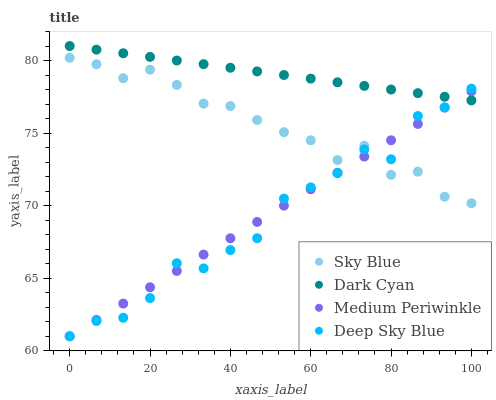Does Deep Sky Blue have the minimum area under the curve?
Answer yes or no. Yes. Does Dark Cyan have the maximum area under the curve?
Answer yes or no. Yes. Does Sky Blue have the minimum area under the curve?
Answer yes or no. No. Does Sky Blue have the maximum area under the curve?
Answer yes or no. No. Is Medium Periwinkle the smoothest?
Answer yes or no. Yes. Is Deep Sky Blue the roughest?
Answer yes or no. Yes. Is Sky Blue the smoothest?
Answer yes or no. No. Is Sky Blue the roughest?
Answer yes or no. No. Does Medium Periwinkle have the lowest value?
Answer yes or no. Yes. Does Sky Blue have the lowest value?
Answer yes or no. No. Does Dark Cyan have the highest value?
Answer yes or no. Yes. Does Sky Blue have the highest value?
Answer yes or no. No. Is Sky Blue less than Dark Cyan?
Answer yes or no. Yes. Is Dark Cyan greater than Sky Blue?
Answer yes or no. Yes. Does Medium Periwinkle intersect Deep Sky Blue?
Answer yes or no. Yes. Is Medium Periwinkle less than Deep Sky Blue?
Answer yes or no. No. Is Medium Periwinkle greater than Deep Sky Blue?
Answer yes or no. No. Does Sky Blue intersect Dark Cyan?
Answer yes or no. No. 